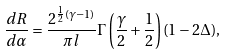Convert formula to latex. <formula><loc_0><loc_0><loc_500><loc_500>\frac { d R } { d \alpha } = \frac { 2 ^ { \frac { 1 } { 2 } ( \gamma - 1 ) } } { { \pi } l } { \Gamma } \left ( \frac { \gamma } { 2 } + \frac { 1 } { 2 } \right ) ( 1 - 2 { \Delta } ) ,</formula> 